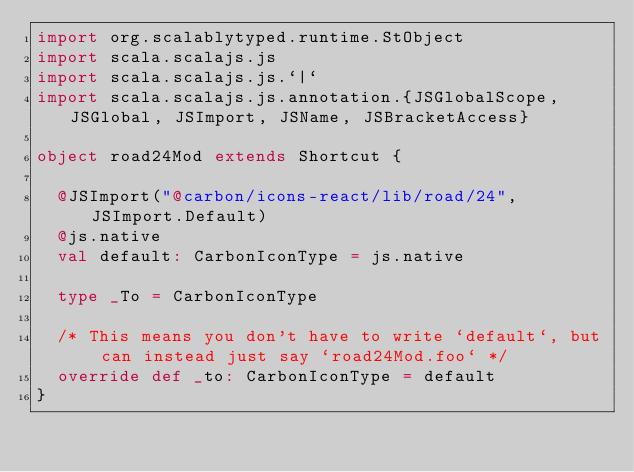Convert code to text. <code><loc_0><loc_0><loc_500><loc_500><_Scala_>import org.scalablytyped.runtime.StObject
import scala.scalajs.js
import scala.scalajs.js.`|`
import scala.scalajs.js.annotation.{JSGlobalScope, JSGlobal, JSImport, JSName, JSBracketAccess}

object road24Mod extends Shortcut {
  
  @JSImport("@carbon/icons-react/lib/road/24", JSImport.Default)
  @js.native
  val default: CarbonIconType = js.native
  
  type _To = CarbonIconType
  
  /* This means you don't have to write `default`, but can instead just say `road24Mod.foo` */
  override def _to: CarbonIconType = default
}
</code> 